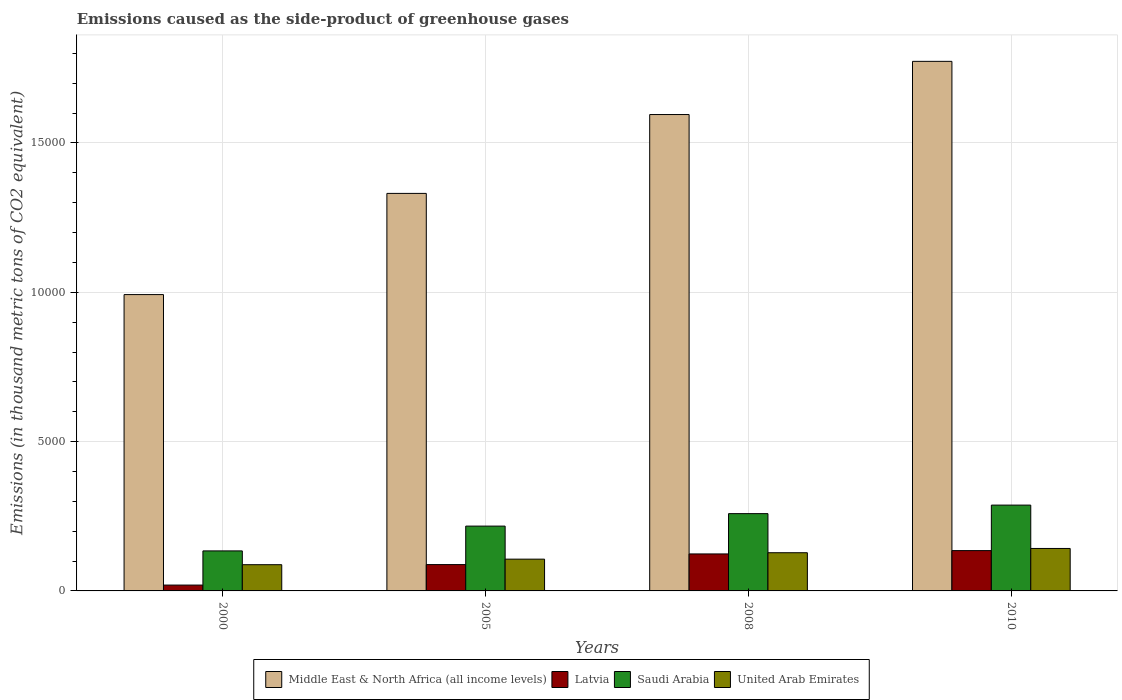How many groups of bars are there?
Your response must be concise. 4. How many bars are there on the 1st tick from the left?
Your response must be concise. 4. In how many cases, is the number of bars for a given year not equal to the number of legend labels?
Your answer should be very brief. 0. What is the emissions caused as the side-product of greenhouse gases in United Arab Emirates in 2010?
Ensure brevity in your answer.  1422. Across all years, what is the maximum emissions caused as the side-product of greenhouse gases in Latvia?
Give a very brief answer. 1350. Across all years, what is the minimum emissions caused as the side-product of greenhouse gases in Latvia?
Provide a short and direct response. 195.7. In which year was the emissions caused as the side-product of greenhouse gases in United Arab Emirates minimum?
Keep it short and to the point. 2000. What is the total emissions caused as the side-product of greenhouse gases in United Arab Emirates in the graph?
Ensure brevity in your answer.  4643.2. What is the difference between the emissions caused as the side-product of greenhouse gases in Middle East & North Africa (all income levels) in 2008 and that in 2010?
Offer a terse response. -1781. What is the difference between the emissions caused as the side-product of greenhouse gases in Saudi Arabia in 2000 and the emissions caused as the side-product of greenhouse gases in United Arab Emirates in 2008?
Offer a very short reply. 61.1. What is the average emissions caused as the side-product of greenhouse gases in United Arab Emirates per year?
Offer a terse response. 1160.8. In the year 2008, what is the difference between the emissions caused as the side-product of greenhouse gases in United Arab Emirates and emissions caused as the side-product of greenhouse gases in Saudi Arabia?
Your answer should be very brief. -1309.3. In how many years, is the emissions caused as the side-product of greenhouse gases in Saudi Arabia greater than 13000 thousand metric tons?
Your answer should be compact. 0. What is the ratio of the emissions caused as the side-product of greenhouse gases in Latvia in 2005 to that in 2008?
Provide a succinct answer. 0.71. Is the difference between the emissions caused as the side-product of greenhouse gases in United Arab Emirates in 2005 and 2008 greater than the difference between the emissions caused as the side-product of greenhouse gases in Saudi Arabia in 2005 and 2008?
Provide a short and direct response. Yes. What is the difference between the highest and the second highest emissions caused as the side-product of greenhouse gases in Middle East & North Africa (all income levels)?
Offer a terse response. 1781. What is the difference between the highest and the lowest emissions caused as the side-product of greenhouse gases in United Arab Emirates?
Ensure brevity in your answer.  543.9. Is the sum of the emissions caused as the side-product of greenhouse gases in Middle East & North Africa (all income levels) in 2000 and 2008 greater than the maximum emissions caused as the side-product of greenhouse gases in Saudi Arabia across all years?
Your answer should be very brief. Yes. What does the 4th bar from the left in 2000 represents?
Offer a very short reply. United Arab Emirates. What does the 4th bar from the right in 2010 represents?
Provide a short and direct response. Middle East & North Africa (all income levels). How many bars are there?
Your answer should be very brief. 16. Are all the bars in the graph horizontal?
Your answer should be very brief. No. How many years are there in the graph?
Give a very brief answer. 4. What is the difference between two consecutive major ticks on the Y-axis?
Ensure brevity in your answer.  5000. Are the values on the major ticks of Y-axis written in scientific E-notation?
Give a very brief answer. No. How are the legend labels stacked?
Ensure brevity in your answer.  Horizontal. What is the title of the graph?
Keep it short and to the point. Emissions caused as the side-product of greenhouse gases. What is the label or title of the X-axis?
Make the answer very short. Years. What is the label or title of the Y-axis?
Keep it short and to the point. Emissions (in thousand metric tons of CO2 equivalent). What is the Emissions (in thousand metric tons of CO2 equivalent) in Middle East & North Africa (all income levels) in 2000?
Offer a terse response. 9923.6. What is the Emissions (in thousand metric tons of CO2 equivalent) of Latvia in 2000?
Make the answer very short. 195.7. What is the Emissions (in thousand metric tons of CO2 equivalent) of Saudi Arabia in 2000?
Give a very brief answer. 1340.1. What is the Emissions (in thousand metric tons of CO2 equivalent) in United Arab Emirates in 2000?
Offer a very short reply. 878.1. What is the Emissions (in thousand metric tons of CO2 equivalent) in Middle East & North Africa (all income levels) in 2005?
Provide a short and direct response. 1.33e+04. What is the Emissions (in thousand metric tons of CO2 equivalent) in Latvia in 2005?
Offer a very short reply. 882.1. What is the Emissions (in thousand metric tons of CO2 equivalent) of Saudi Arabia in 2005?
Your answer should be compact. 2170.7. What is the Emissions (in thousand metric tons of CO2 equivalent) in United Arab Emirates in 2005?
Provide a succinct answer. 1064.1. What is the Emissions (in thousand metric tons of CO2 equivalent) in Middle East & North Africa (all income levels) in 2008?
Ensure brevity in your answer.  1.60e+04. What is the Emissions (in thousand metric tons of CO2 equivalent) of Latvia in 2008?
Your response must be concise. 1238.6. What is the Emissions (in thousand metric tons of CO2 equivalent) of Saudi Arabia in 2008?
Keep it short and to the point. 2588.3. What is the Emissions (in thousand metric tons of CO2 equivalent) in United Arab Emirates in 2008?
Make the answer very short. 1279. What is the Emissions (in thousand metric tons of CO2 equivalent) in Middle East & North Africa (all income levels) in 2010?
Provide a short and direct response. 1.77e+04. What is the Emissions (in thousand metric tons of CO2 equivalent) of Latvia in 2010?
Your answer should be very brief. 1350. What is the Emissions (in thousand metric tons of CO2 equivalent) of Saudi Arabia in 2010?
Give a very brief answer. 2874. What is the Emissions (in thousand metric tons of CO2 equivalent) in United Arab Emirates in 2010?
Your answer should be very brief. 1422. Across all years, what is the maximum Emissions (in thousand metric tons of CO2 equivalent) of Middle East & North Africa (all income levels)?
Keep it short and to the point. 1.77e+04. Across all years, what is the maximum Emissions (in thousand metric tons of CO2 equivalent) of Latvia?
Offer a very short reply. 1350. Across all years, what is the maximum Emissions (in thousand metric tons of CO2 equivalent) of Saudi Arabia?
Your answer should be compact. 2874. Across all years, what is the maximum Emissions (in thousand metric tons of CO2 equivalent) in United Arab Emirates?
Make the answer very short. 1422. Across all years, what is the minimum Emissions (in thousand metric tons of CO2 equivalent) in Middle East & North Africa (all income levels)?
Your answer should be very brief. 9923.6. Across all years, what is the minimum Emissions (in thousand metric tons of CO2 equivalent) of Latvia?
Offer a terse response. 195.7. Across all years, what is the minimum Emissions (in thousand metric tons of CO2 equivalent) in Saudi Arabia?
Provide a short and direct response. 1340.1. Across all years, what is the minimum Emissions (in thousand metric tons of CO2 equivalent) in United Arab Emirates?
Offer a terse response. 878.1. What is the total Emissions (in thousand metric tons of CO2 equivalent) in Middle East & North Africa (all income levels) in the graph?
Provide a succinct answer. 5.69e+04. What is the total Emissions (in thousand metric tons of CO2 equivalent) of Latvia in the graph?
Your response must be concise. 3666.4. What is the total Emissions (in thousand metric tons of CO2 equivalent) of Saudi Arabia in the graph?
Offer a very short reply. 8973.1. What is the total Emissions (in thousand metric tons of CO2 equivalent) of United Arab Emirates in the graph?
Provide a short and direct response. 4643.2. What is the difference between the Emissions (in thousand metric tons of CO2 equivalent) of Middle East & North Africa (all income levels) in 2000 and that in 2005?
Keep it short and to the point. -3388.4. What is the difference between the Emissions (in thousand metric tons of CO2 equivalent) of Latvia in 2000 and that in 2005?
Give a very brief answer. -686.4. What is the difference between the Emissions (in thousand metric tons of CO2 equivalent) of Saudi Arabia in 2000 and that in 2005?
Make the answer very short. -830.6. What is the difference between the Emissions (in thousand metric tons of CO2 equivalent) in United Arab Emirates in 2000 and that in 2005?
Your response must be concise. -186. What is the difference between the Emissions (in thousand metric tons of CO2 equivalent) of Middle East & North Africa (all income levels) in 2000 and that in 2008?
Your answer should be very brief. -6029.4. What is the difference between the Emissions (in thousand metric tons of CO2 equivalent) of Latvia in 2000 and that in 2008?
Make the answer very short. -1042.9. What is the difference between the Emissions (in thousand metric tons of CO2 equivalent) in Saudi Arabia in 2000 and that in 2008?
Ensure brevity in your answer.  -1248.2. What is the difference between the Emissions (in thousand metric tons of CO2 equivalent) in United Arab Emirates in 2000 and that in 2008?
Give a very brief answer. -400.9. What is the difference between the Emissions (in thousand metric tons of CO2 equivalent) of Middle East & North Africa (all income levels) in 2000 and that in 2010?
Make the answer very short. -7810.4. What is the difference between the Emissions (in thousand metric tons of CO2 equivalent) of Latvia in 2000 and that in 2010?
Make the answer very short. -1154.3. What is the difference between the Emissions (in thousand metric tons of CO2 equivalent) of Saudi Arabia in 2000 and that in 2010?
Give a very brief answer. -1533.9. What is the difference between the Emissions (in thousand metric tons of CO2 equivalent) in United Arab Emirates in 2000 and that in 2010?
Keep it short and to the point. -543.9. What is the difference between the Emissions (in thousand metric tons of CO2 equivalent) in Middle East & North Africa (all income levels) in 2005 and that in 2008?
Offer a terse response. -2641. What is the difference between the Emissions (in thousand metric tons of CO2 equivalent) of Latvia in 2005 and that in 2008?
Keep it short and to the point. -356.5. What is the difference between the Emissions (in thousand metric tons of CO2 equivalent) in Saudi Arabia in 2005 and that in 2008?
Offer a terse response. -417.6. What is the difference between the Emissions (in thousand metric tons of CO2 equivalent) of United Arab Emirates in 2005 and that in 2008?
Your answer should be very brief. -214.9. What is the difference between the Emissions (in thousand metric tons of CO2 equivalent) in Middle East & North Africa (all income levels) in 2005 and that in 2010?
Offer a terse response. -4422. What is the difference between the Emissions (in thousand metric tons of CO2 equivalent) of Latvia in 2005 and that in 2010?
Your answer should be very brief. -467.9. What is the difference between the Emissions (in thousand metric tons of CO2 equivalent) of Saudi Arabia in 2005 and that in 2010?
Your response must be concise. -703.3. What is the difference between the Emissions (in thousand metric tons of CO2 equivalent) in United Arab Emirates in 2005 and that in 2010?
Give a very brief answer. -357.9. What is the difference between the Emissions (in thousand metric tons of CO2 equivalent) of Middle East & North Africa (all income levels) in 2008 and that in 2010?
Ensure brevity in your answer.  -1781. What is the difference between the Emissions (in thousand metric tons of CO2 equivalent) in Latvia in 2008 and that in 2010?
Your answer should be very brief. -111.4. What is the difference between the Emissions (in thousand metric tons of CO2 equivalent) of Saudi Arabia in 2008 and that in 2010?
Offer a terse response. -285.7. What is the difference between the Emissions (in thousand metric tons of CO2 equivalent) of United Arab Emirates in 2008 and that in 2010?
Ensure brevity in your answer.  -143. What is the difference between the Emissions (in thousand metric tons of CO2 equivalent) in Middle East & North Africa (all income levels) in 2000 and the Emissions (in thousand metric tons of CO2 equivalent) in Latvia in 2005?
Keep it short and to the point. 9041.5. What is the difference between the Emissions (in thousand metric tons of CO2 equivalent) of Middle East & North Africa (all income levels) in 2000 and the Emissions (in thousand metric tons of CO2 equivalent) of Saudi Arabia in 2005?
Give a very brief answer. 7752.9. What is the difference between the Emissions (in thousand metric tons of CO2 equivalent) in Middle East & North Africa (all income levels) in 2000 and the Emissions (in thousand metric tons of CO2 equivalent) in United Arab Emirates in 2005?
Offer a terse response. 8859.5. What is the difference between the Emissions (in thousand metric tons of CO2 equivalent) in Latvia in 2000 and the Emissions (in thousand metric tons of CO2 equivalent) in Saudi Arabia in 2005?
Offer a terse response. -1975. What is the difference between the Emissions (in thousand metric tons of CO2 equivalent) of Latvia in 2000 and the Emissions (in thousand metric tons of CO2 equivalent) of United Arab Emirates in 2005?
Keep it short and to the point. -868.4. What is the difference between the Emissions (in thousand metric tons of CO2 equivalent) of Saudi Arabia in 2000 and the Emissions (in thousand metric tons of CO2 equivalent) of United Arab Emirates in 2005?
Keep it short and to the point. 276. What is the difference between the Emissions (in thousand metric tons of CO2 equivalent) in Middle East & North Africa (all income levels) in 2000 and the Emissions (in thousand metric tons of CO2 equivalent) in Latvia in 2008?
Make the answer very short. 8685. What is the difference between the Emissions (in thousand metric tons of CO2 equivalent) in Middle East & North Africa (all income levels) in 2000 and the Emissions (in thousand metric tons of CO2 equivalent) in Saudi Arabia in 2008?
Keep it short and to the point. 7335.3. What is the difference between the Emissions (in thousand metric tons of CO2 equivalent) in Middle East & North Africa (all income levels) in 2000 and the Emissions (in thousand metric tons of CO2 equivalent) in United Arab Emirates in 2008?
Your answer should be very brief. 8644.6. What is the difference between the Emissions (in thousand metric tons of CO2 equivalent) of Latvia in 2000 and the Emissions (in thousand metric tons of CO2 equivalent) of Saudi Arabia in 2008?
Your answer should be very brief. -2392.6. What is the difference between the Emissions (in thousand metric tons of CO2 equivalent) of Latvia in 2000 and the Emissions (in thousand metric tons of CO2 equivalent) of United Arab Emirates in 2008?
Offer a terse response. -1083.3. What is the difference between the Emissions (in thousand metric tons of CO2 equivalent) of Saudi Arabia in 2000 and the Emissions (in thousand metric tons of CO2 equivalent) of United Arab Emirates in 2008?
Provide a short and direct response. 61.1. What is the difference between the Emissions (in thousand metric tons of CO2 equivalent) of Middle East & North Africa (all income levels) in 2000 and the Emissions (in thousand metric tons of CO2 equivalent) of Latvia in 2010?
Keep it short and to the point. 8573.6. What is the difference between the Emissions (in thousand metric tons of CO2 equivalent) in Middle East & North Africa (all income levels) in 2000 and the Emissions (in thousand metric tons of CO2 equivalent) in Saudi Arabia in 2010?
Provide a short and direct response. 7049.6. What is the difference between the Emissions (in thousand metric tons of CO2 equivalent) in Middle East & North Africa (all income levels) in 2000 and the Emissions (in thousand metric tons of CO2 equivalent) in United Arab Emirates in 2010?
Provide a short and direct response. 8501.6. What is the difference between the Emissions (in thousand metric tons of CO2 equivalent) of Latvia in 2000 and the Emissions (in thousand metric tons of CO2 equivalent) of Saudi Arabia in 2010?
Your answer should be compact. -2678.3. What is the difference between the Emissions (in thousand metric tons of CO2 equivalent) in Latvia in 2000 and the Emissions (in thousand metric tons of CO2 equivalent) in United Arab Emirates in 2010?
Your response must be concise. -1226.3. What is the difference between the Emissions (in thousand metric tons of CO2 equivalent) in Saudi Arabia in 2000 and the Emissions (in thousand metric tons of CO2 equivalent) in United Arab Emirates in 2010?
Your answer should be very brief. -81.9. What is the difference between the Emissions (in thousand metric tons of CO2 equivalent) of Middle East & North Africa (all income levels) in 2005 and the Emissions (in thousand metric tons of CO2 equivalent) of Latvia in 2008?
Offer a very short reply. 1.21e+04. What is the difference between the Emissions (in thousand metric tons of CO2 equivalent) in Middle East & North Africa (all income levels) in 2005 and the Emissions (in thousand metric tons of CO2 equivalent) in Saudi Arabia in 2008?
Your response must be concise. 1.07e+04. What is the difference between the Emissions (in thousand metric tons of CO2 equivalent) in Middle East & North Africa (all income levels) in 2005 and the Emissions (in thousand metric tons of CO2 equivalent) in United Arab Emirates in 2008?
Your response must be concise. 1.20e+04. What is the difference between the Emissions (in thousand metric tons of CO2 equivalent) of Latvia in 2005 and the Emissions (in thousand metric tons of CO2 equivalent) of Saudi Arabia in 2008?
Your response must be concise. -1706.2. What is the difference between the Emissions (in thousand metric tons of CO2 equivalent) of Latvia in 2005 and the Emissions (in thousand metric tons of CO2 equivalent) of United Arab Emirates in 2008?
Provide a succinct answer. -396.9. What is the difference between the Emissions (in thousand metric tons of CO2 equivalent) of Saudi Arabia in 2005 and the Emissions (in thousand metric tons of CO2 equivalent) of United Arab Emirates in 2008?
Your answer should be compact. 891.7. What is the difference between the Emissions (in thousand metric tons of CO2 equivalent) in Middle East & North Africa (all income levels) in 2005 and the Emissions (in thousand metric tons of CO2 equivalent) in Latvia in 2010?
Provide a succinct answer. 1.20e+04. What is the difference between the Emissions (in thousand metric tons of CO2 equivalent) in Middle East & North Africa (all income levels) in 2005 and the Emissions (in thousand metric tons of CO2 equivalent) in Saudi Arabia in 2010?
Offer a very short reply. 1.04e+04. What is the difference between the Emissions (in thousand metric tons of CO2 equivalent) of Middle East & North Africa (all income levels) in 2005 and the Emissions (in thousand metric tons of CO2 equivalent) of United Arab Emirates in 2010?
Keep it short and to the point. 1.19e+04. What is the difference between the Emissions (in thousand metric tons of CO2 equivalent) in Latvia in 2005 and the Emissions (in thousand metric tons of CO2 equivalent) in Saudi Arabia in 2010?
Provide a short and direct response. -1991.9. What is the difference between the Emissions (in thousand metric tons of CO2 equivalent) in Latvia in 2005 and the Emissions (in thousand metric tons of CO2 equivalent) in United Arab Emirates in 2010?
Make the answer very short. -539.9. What is the difference between the Emissions (in thousand metric tons of CO2 equivalent) of Saudi Arabia in 2005 and the Emissions (in thousand metric tons of CO2 equivalent) of United Arab Emirates in 2010?
Provide a succinct answer. 748.7. What is the difference between the Emissions (in thousand metric tons of CO2 equivalent) of Middle East & North Africa (all income levels) in 2008 and the Emissions (in thousand metric tons of CO2 equivalent) of Latvia in 2010?
Make the answer very short. 1.46e+04. What is the difference between the Emissions (in thousand metric tons of CO2 equivalent) in Middle East & North Africa (all income levels) in 2008 and the Emissions (in thousand metric tons of CO2 equivalent) in Saudi Arabia in 2010?
Offer a very short reply. 1.31e+04. What is the difference between the Emissions (in thousand metric tons of CO2 equivalent) of Middle East & North Africa (all income levels) in 2008 and the Emissions (in thousand metric tons of CO2 equivalent) of United Arab Emirates in 2010?
Give a very brief answer. 1.45e+04. What is the difference between the Emissions (in thousand metric tons of CO2 equivalent) in Latvia in 2008 and the Emissions (in thousand metric tons of CO2 equivalent) in Saudi Arabia in 2010?
Offer a very short reply. -1635.4. What is the difference between the Emissions (in thousand metric tons of CO2 equivalent) of Latvia in 2008 and the Emissions (in thousand metric tons of CO2 equivalent) of United Arab Emirates in 2010?
Give a very brief answer. -183.4. What is the difference between the Emissions (in thousand metric tons of CO2 equivalent) in Saudi Arabia in 2008 and the Emissions (in thousand metric tons of CO2 equivalent) in United Arab Emirates in 2010?
Your response must be concise. 1166.3. What is the average Emissions (in thousand metric tons of CO2 equivalent) in Middle East & North Africa (all income levels) per year?
Offer a very short reply. 1.42e+04. What is the average Emissions (in thousand metric tons of CO2 equivalent) of Latvia per year?
Offer a terse response. 916.6. What is the average Emissions (in thousand metric tons of CO2 equivalent) of Saudi Arabia per year?
Give a very brief answer. 2243.28. What is the average Emissions (in thousand metric tons of CO2 equivalent) in United Arab Emirates per year?
Provide a short and direct response. 1160.8. In the year 2000, what is the difference between the Emissions (in thousand metric tons of CO2 equivalent) in Middle East & North Africa (all income levels) and Emissions (in thousand metric tons of CO2 equivalent) in Latvia?
Provide a succinct answer. 9727.9. In the year 2000, what is the difference between the Emissions (in thousand metric tons of CO2 equivalent) of Middle East & North Africa (all income levels) and Emissions (in thousand metric tons of CO2 equivalent) of Saudi Arabia?
Keep it short and to the point. 8583.5. In the year 2000, what is the difference between the Emissions (in thousand metric tons of CO2 equivalent) of Middle East & North Africa (all income levels) and Emissions (in thousand metric tons of CO2 equivalent) of United Arab Emirates?
Give a very brief answer. 9045.5. In the year 2000, what is the difference between the Emissions (in thousand metric tons of CO2 equivalent) in Latvia and Emissions (in thousand metric tons of CO2 equivalent) in Saudi Arabia?
Give a very brief answer. -1144.4. In the year 2000, what is the difference between the Emissions (in thousand metric tons of CO2 equivalent) in Latvia and Emissions (in thousand metric tons of CO2 equivalent) in United Arab Emirates?
Your answer should be compact. -682.4. In the year 2000, what is the difference between the Emissions (in thousand metric tons of CO2 equivalent) of Saudi Arabia and Emissions (in thousand metric tons of CO2 equivalent) of United Arab Emirates?
Your answer should be very brief. 462. In the year 2005, what is the difference between the Emissions (in thousand metric tons of CO2 equivalent) of Middle East & North Africa (all income levels) and Emissions (in thousand metric tons of CO2 equivalent) of Latvia?
Make the answer very short. 1.24e+04. In the year 2005, what is the difference between the Emissions (in thousand metric tons of CO2 equivalent) of Middle East & North Africa (all income levels) and Emissions (in thousand metric tons of CO2 equivalent) of Saudi Arabia?
Give a very brief answer. 1.11e+04. In the year 2005, what is the difference between the Emissions (in thousand metric tons of CO2 equivalent) in Middle East & North Africa (all income levels) and Emissions (in thousand metric tons of CO2 equivalent) in United Arab Emirates?
Your response must be concise. 1.22e+04. In the year 2005, what is the difference between the Emissions (in thousand metric tons of CO2 equivalent) in Latvia and Emissions (in thousand metric tons of CO2 equivalent) in Saudi Arabia?
Your answer should be very brief. -1288.6. In the year 2005, what is the difference between the Emissions (in thousand metric tons of CO2 equivalent) in Latvia and Emissions (in thousand metric tons of CO2 equivalent) in United Arab Emirates?
Your response must be concise. -182. In the year 2005, what is the difference between the Emissions (in thousand metric tons of CO2 equivalent) in Saudi Arabia and Emissions (in thousand metric tons of CO2 equivalent) in United Arab Emirates?
Make the answer very short. 1106.6. In the year 2008, what is the difference between the Emissions (in thousand metric tons of CO2 equivalent) of Middle East & North Africa (all income levels) and Emissions (in thousand metric tons of CO2 equivalent) of Latvia?
Offer a terse response. 1.47e+04. In the year 2008, what is the difference between the Emissions (in thousand metric tons of CO2 equivalent) of Middle East & North Africa (all income levels) and Emissions (in thousand metric tons of CO2 equivalent) of Saudi Arabia?
Your answer should be very brief. 1.34e+04. In the year 2008, what is the difference between the Emissions (in thousand metric tons of CO2 equivalent) in Middle East & North Africa (all income levels) and Emissions (in thousand metric tons of CO2 equivalent) in United Arab Emirates?
Offer a terse response. 1.47e+04. In the year 2008, what is the difference between the Emissions (in thousand metric tons of CO2 equivalent) of Latvia and Emissions (in thousand metric tons of CO2 equivalent) of Saudi Arabia?
Your answer should be compact. -1349.7. In the year 2008, what is the difference between the Emissions (in thousand metric tons of CO2 equivalent) in Latvia and Emissions (in thousand metric tons of CO2 equivalent) in United Arab Emirates?
Offer a terse response. -40.4. In the year 2008, what is the difference between the Emissions (in thousand metric tons of CO2 equivalent) of Saudi Arabia and Emissions (in thousand metric tons of CO2 equivalent) of United Arab Emirates?
Ensure brevity in your answer.  1309.3. In the year 2010, what is the difference between the Emissions (in thousand metric tons of CO2 equivalent) of Middle East & North Africa (all income levels) and Emissions (in thousand metric tons of CO2 equivalent) of Latvia?
Make the answer very short. 1.64e+04. In the year 2010, what is the difference between the Emissions (in thousand metric tons of CO2 equivalent) of Middle East & North Africa (all income levels) and Emissions (in thousand metric tons of CO2 equivalent) of Saudi Arabia?
Offer a terse response. 1.49e+04. In the year 2010, what is the difference between the Emissions (in thousand metric tons of CO2 equivalent) of Middle East & North Africa (all income levels) and Emissions (in thousand metric tons of CO2 equivalent) of United Arab Emirates?
Keep it short and to the point. 1.63e+04. In the year 2010, what is the difference between the Emissions (in thousand metric tons of CO2 equivalent) of Latvia and Emissions (in thousand metric tons of CO2 equivalent) of Saudi Arabia?
Keep it short and to the point. -1524. In the year 2010, what is the difference between the Emissions (in thousand metric tons of CO2 equivalent) of Latvia and Emissions (in thousand metric tons of CO2 equivalent) of United Arab Emirates?
Ensure brevity in your answer.  -72. In the year 2010, what is the difference between the Emissions (in thousand metric tons of CO2 equivalent) in Saudi Arabia and Emissions (in thousand metric tons of CO2 equivalent) in United Arab Emirates?
Ensure brevity in your answer.  1452. What is the ratio of the Emissions (in thousand metric tons of CO2 equivalent) of Middle East & North Africa (all income levels) in 2000 to that in 2005?
Offer a very short reply. 0.75. What is the ratio of the Emissions (in thousand metric tons of CO2 equivalent) of Latvia in 2000 to that in 2005?
Your answer should be very brief. 0.22. What is the ratio of the Emissions (in thousand metric tons of CO2 equivalent) in Saudi Arabia in 2000 to that in 2005?
Offer a very short reply. 0.62. What is the ratio of the Emissions (in thousand metric tons of CO2 equivalent) of United Arab Emirates in 2000 to that in 2005?
Give a very brief answer. 0.83. What is the ratio of the Emissions (in thousand metric tons of CO2 equivalent) of Middle East & North Africa (all income levels) in 2000 to that in 2008?
Ensure brevity in your answer.  0.62. What is the ratio of the Emissions (in thousand metric tons of CO2 equivalent) of Latvia in 2000 to that in 2008?
Ensure brevity in your answer.  0.16. What is the ratio of the Emissions (in thousand metric tons of CO2 equivalent) of Saudi Arabia in 2000 to that in 2008?
Give a very brief answer. 0.52. What is the ratio of the Emissions (in thousand metric tons of CO2 equivalent) of United Arab Emirates in 2000 to that in 2008?
Offer a very short reply. 0.69. What is the ratio of the Emissions (in thousand metric tons of CO2 equivalent) of Middle East & North Africa (all income levels) in 2000 to that in 2010?
Offer a terse response. 0.56. What is the ratio of the Emissions (in thousand metric tons of CO2 equivalent) in Latvia in 2000 to that in 2010?
Your answer should be very brief. 0.14. What is the ratio of the Emissions (in thousand metric tons of CO2 equivalent) of Saudi Arabia in 2000 to that in 2010?
Provide a succinct answer. 0.47. What is the ratio of the Emissions (in thousand metric tons of CO2 equivalent) in United Arab Emirates in 2000 to that in 2010?
Your answer should be compact. 0.62. What is the ratio of the Emissions (in thousand metric tons of CO2 equivalent) in Middle East & North Africa (all income levels) in 2005 to that in 2008?
Offer a terse response. 0.83. What is the ratio of the Emissions (in thousand metric tons of CO2 equivalent) of Latvia in 2005 to that in 2008?
Ensure brevity in your answer.  0.71. What is the ratio of the Emissions (in thousand metric tons of CO2 equivalent) in Saudi Arabia in 2005 to that in 2008?
Offer a very short reply. 0.84. What is the ratio of the Emissions (in thousand metric tons of CO2 equivalent) in United Arab Emirates in 2005 to that in 2008?
Your response must be concise. 0.83. What is the ratio of the Emissions (in thousand metric tons of CO2 equivalent) in Middle East & North Africa (all income levels) in 2005 to that in 2010?
Provide a succinct answer. 0.75. What is the ratio of the Emissions (in thousand metric tons of CO2 equivalent) in Latvia in 2005 to that in 2010?
Ensure brevity in your answer.  0.65. What is the ratio of the Emissions (in thousand metric tons of CO2 equivalent) of Saudi Arabia in 2005 to that in 2010?
Provide a succinct answer. 0.76. What is the ratio of the Emissions (in thousand metric tons of CO2 equivalent) of United Arab Emirates in 2005 to that in 2010?
Provide a short and direct response. 0.75. What is the ratio of the Emissions (in thousand metric tons of CO2 equivalent) of Middle East & North Africa (all income levels) in 2008 to that in 2010?
Make the answer very short. 0.9. What is the ratio of the Emissions (in thousand metric tons of CO2 equivalent) in Latvia in 2008 to that in 2010?
Provide a succinct answer. 0.92. What is the ratio of the Emissions (in thousand metric tons of CO2 equivalent) in Saudi Arabia in 2008 to that in 2010?
Your answer should be compact. 0.9. What is the ratio of the Emissions (in thousand metric tons of CO2 equivalent) in United Arab Emirates in 2008 to that in 2010?
Provide a short and direct response. 0.9. What is the difference between the highest and the second highest Emissions (in thousand metric tons of CO2 equivalent) in Middle East & North Africa (all income levels)?
Keep it short and to the point. 1781. What is the difference between the highest and the second highest Emissions (in thousand metric tons of CO2 equivalent) in Latvia?
Offer a terse response. 111.4. What is the difference between the highest and the second highest Emissions (in thousand metric tons of CO2 equivalent) in Saudi Arabia?
Ensure brevity in your answer.  285.7. What is the difference between the highest and the second highest Emissions (in thousand metric tons of CO2 equivalent) in United Arab Emirates?
Provide a short and direct response. 143. What is the difference between the highest and the lowest Emissions (in thousand metric tons of CO2 equivalent) in Middle East & North Africa (all income levels)?
Offer a very short reply. 7810.4. What is the difference between the highest and the lowest Emissions (in thousand metric tons of CO2 equivalent) in Latvia?
Ensure brevity in your answer.  1154.3. What is the difference between the highest and the lowest Emissions (in thousand metric tons of CO2 equivalent) in Saudi Arabia?
Keep it short and to the point. 1533.9. What is the difference between the highest and the lowest Emissions (in thousand metric tons of CO2 equivalent) of United Arab Emirates?
Ensure brevity in your answer.  543.9. 